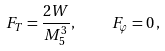<formula> <loc_0><loc_0><loc_500><loc_500>F _ { T } = \frac { 2 W } { M ^ { 3 } _ { 5 } } , \quad F _ { \varphi } = 0 \, ,</formula> 